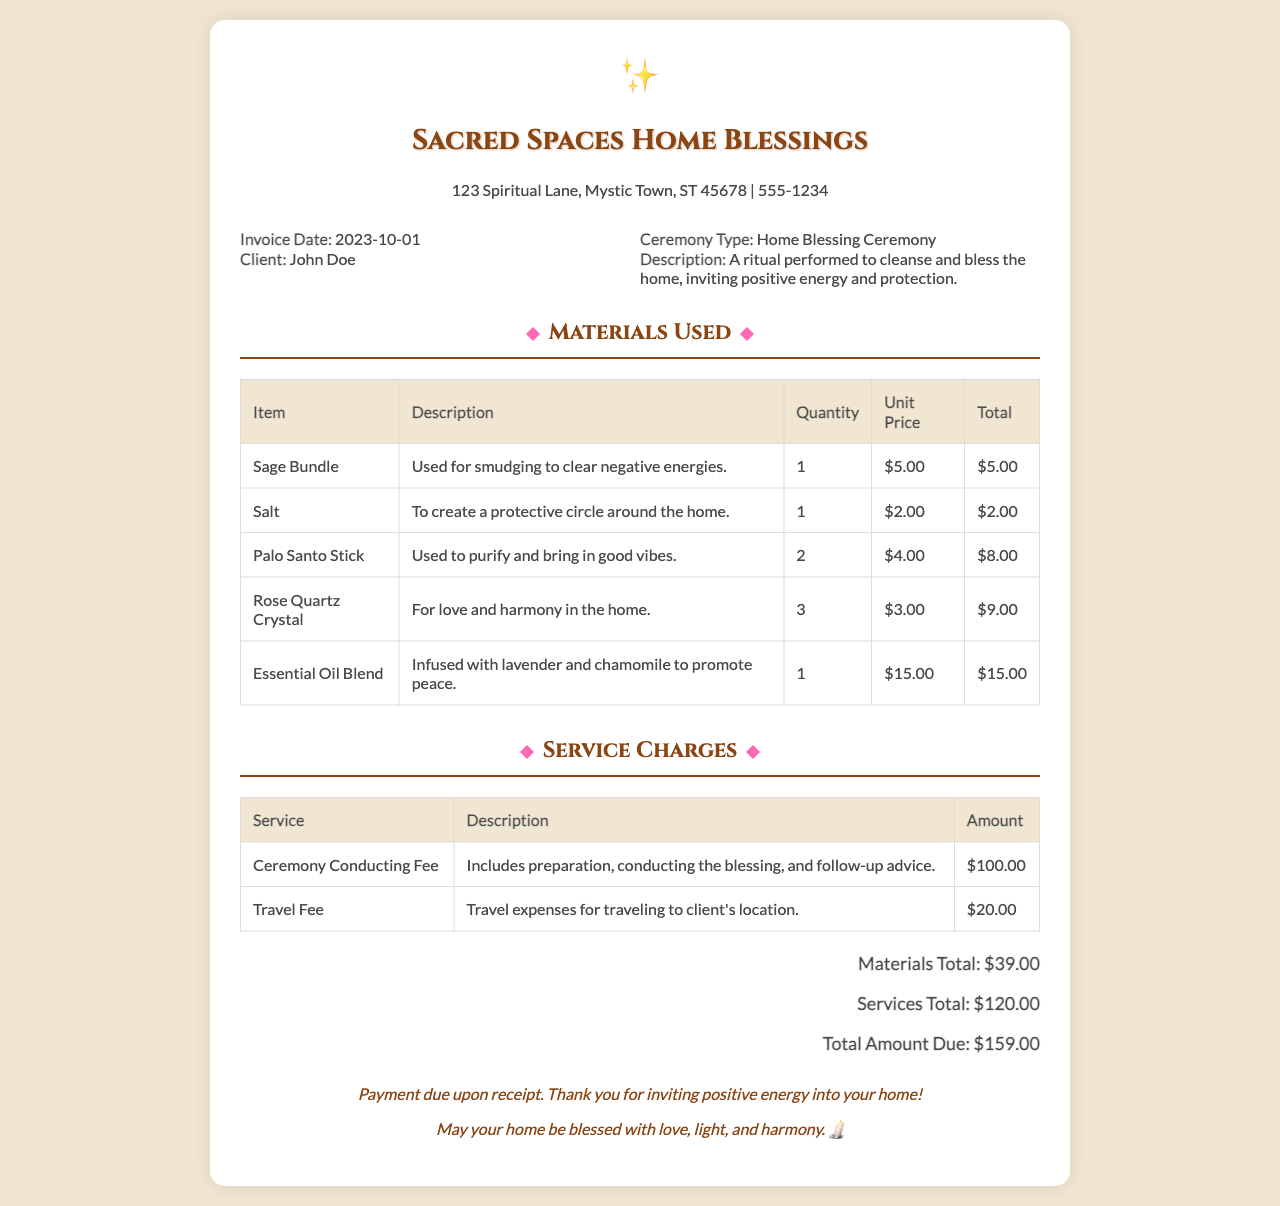What is the invoice date? The invoice date is specified at the top of the document under the details section.
Answer: 2023-10-01 Who is the client? The client's name is mentioned in the details section alongside the invoice date.
Answer: John Doe What is the total amount due? The total amount due is provided at the bottom of the receipt under the total section.
Answer: $159.00 How much does the Ceremony Conducting Fee cost? This fee is listed in the service charges table with its corresponding amount.
Answer: $100.00 What item is used for smudging? The item used for smudging is listed in the materials used section with its description.
Answer: Sage Bundle How many Rose Quartz Crystals were used? The quantity of Rose Quartz Crystals is specified in the materials table.
Answer: 3 What are the primary ingredients in the Essential Oil Blend? The ingredients of the Essential Oil Blend are described in its entry in the materials used table.
Answer: Lavender and chamomile What service charge is related to travel? One of the service charges listed specifically mentions travel expenses.
Answer: Travel Fee What is the total for materials used? The materials total is summarized at the bottom of the materials used section.
Answer: $39.00 